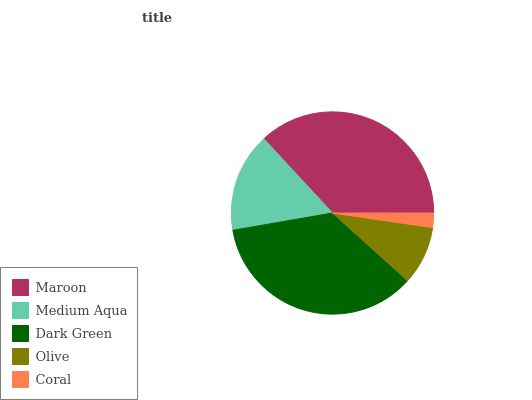Is Coral the minimum?
Answer yes or no. Yes. Is Maroon the maximum?
Answer yes or no. Yes. Is Medium Aqua the minimum?
Answer yes or no. No. Is Medium Aqua the maximum?
Answer yes or no. No. Is Maroon greater than Medium Aqua?
Answer yes or no. Yes. Is Medium Aqua less than Maroon?
Answer yes or no. Yes. Is Medium Aqua greater than Maroon?
Answer yes or no. No. Is Maroon less than Medium Aqua?
Answer yes or no. No. Is Medium Aqua the high median?
Answer yes or no. Yes. Is Medium Aqua the low median?
Answer yes or no. Yes. Is Coral the high median?
Answer yes or no. No. Is Maroon the low median?
Answer yes or no. No. 